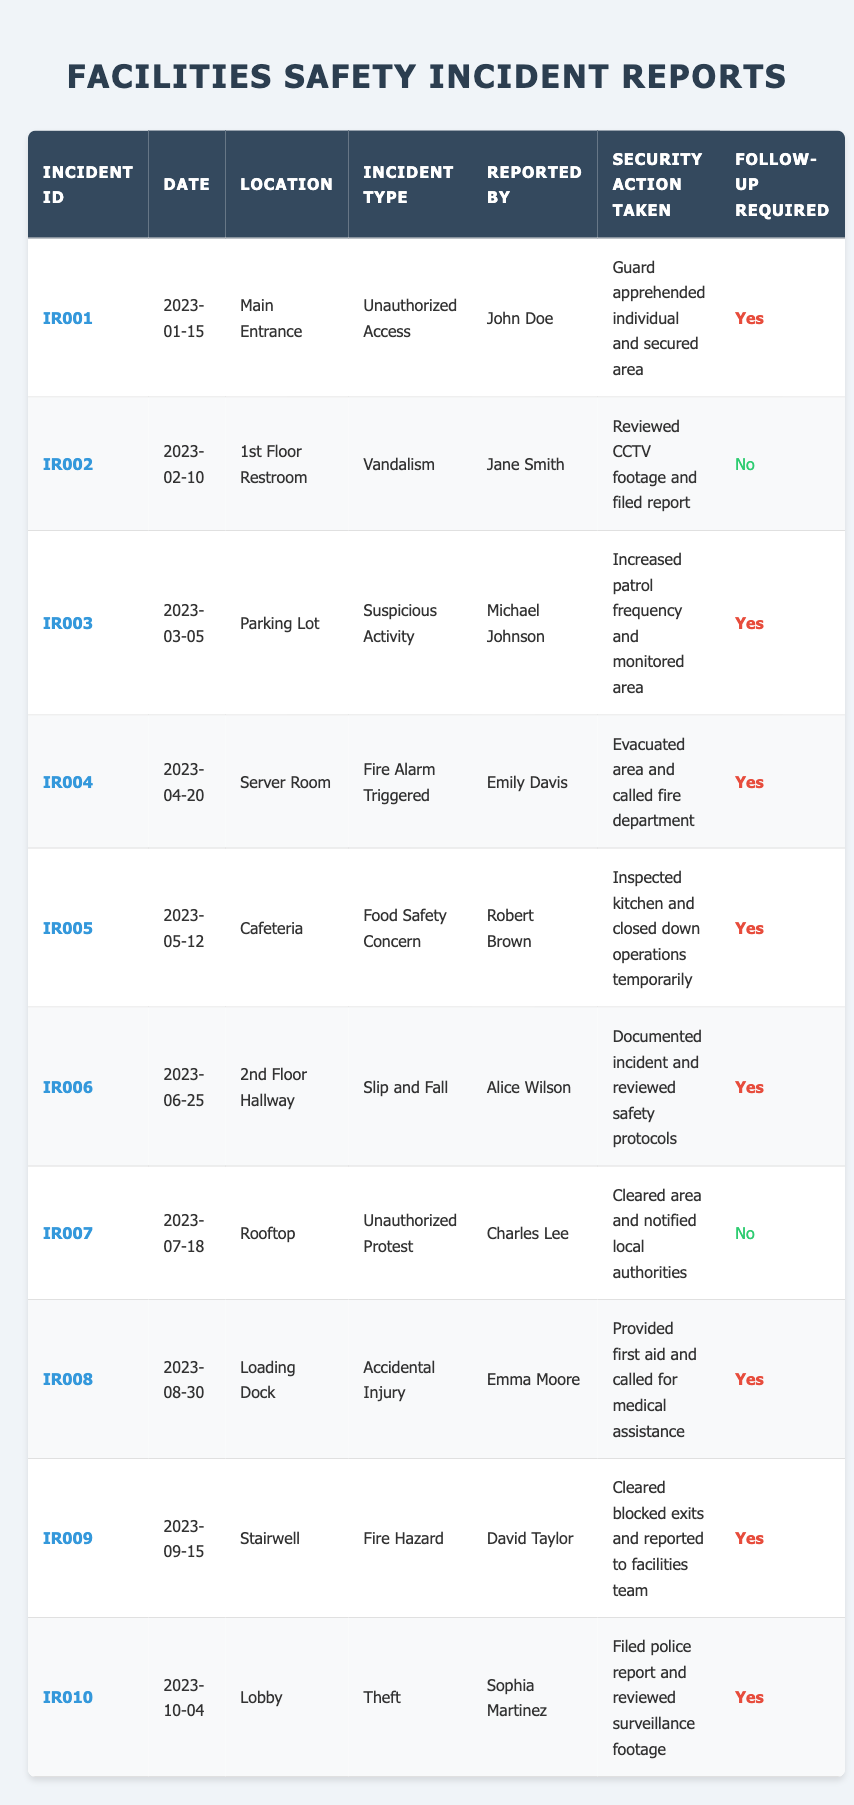What was the date of the incident involving unauthorized access? The table lists the incident ID IR001 for unauthorized access, which occurred on 2023-01-15.
Answer: 2023-01-15 How many incidents require follow-up? By checking the table, there are a total of 7 incidents that indicate "Yes" for follow-up required.
Answer: 7 Who reported the incident of vandalism? The table shows that the incident ID IR002 for vandalism was reported by Jane Smith.
Answer: Jane Smith Is there any incident related to food safety concerns? Checking the incident types in the table, IR005 is related to food safety concerns, reported by Robert Brown.
Answer: Yes How many incidents occurred in the cafeteria? The table shows only one incident with location "Cafeteria," which is IR005 regarding a food safety concern.
Answer: 1 What is the security action taken for the fire alarm triggered incident? The incident IR004 in the table indicates that the area was evacuated and the fire department was called.
Answer: Evacuated area and called fire department Was there any incident on the rooftop? Yes, incident ID IR007 is reported on the rooftop and involved unauthorized protest.
Answer: Yes Which incident was reported on August 30, 2023? Referring to the table, incident ID IR008 pertains to accidental injury and occurred on that date.
Answer: IR008 What is the total number of incidents between January and June? Counting the incidents from the table, there are IR001 (January), IR002 (February), IR003 (March), IR004 (April), IR005 (May), and IR006 (June), totaling 6 incidents.
Answer: 6 Which incident was reported by Sophia Martinez? The table indicates that Sophia Martinez reported the theft incident, which has ID IR010.
Answer: IR010 How many of the reported incidents were related to safety hazards? Examining the table, incidents related to safety hazards are IR004 (Fire Alarm Triggered), IR006 (Slip and Fall), IR008 (Accidental Injury), and IR009 (Fire Hazard), totaling 4.
Answer: 4 Was any security action taken for the suspicious activity incident? Yes, the table shows that for suspicious activity reported by Michael Johnson (IR003), increased patrol frequency and area monitoring were the actions taken.
Answer: Yes How many incidents reported by Alice Wilson required follow-up? The table shows Alice Wilson reported one incident, which was IR006 (Slip and Fall), and it required follow-up.
Answer: 1 Was there a fire hazard reported in the stairwell? Yes, incident ID IR009 indicates a fire hazard was reported in the stairwell.
Answer: Yes What action was taken for the incident reported by Emma Moore? According to the table, for the accidental injury incident (IR008), first aid was provided and medical assistance was called.
Answer: Provided first aid and called for medical assistance Which location had the most incidents reported? The table indicates multiple incidents at different locations; Main Entrance, Cafeteria, and Loading Dock each have one incident, but the specific counts need a holistic review and none is repeated. Therefore, there is no single location with multiple incidents.
Answer: No single location has multiple incidents 